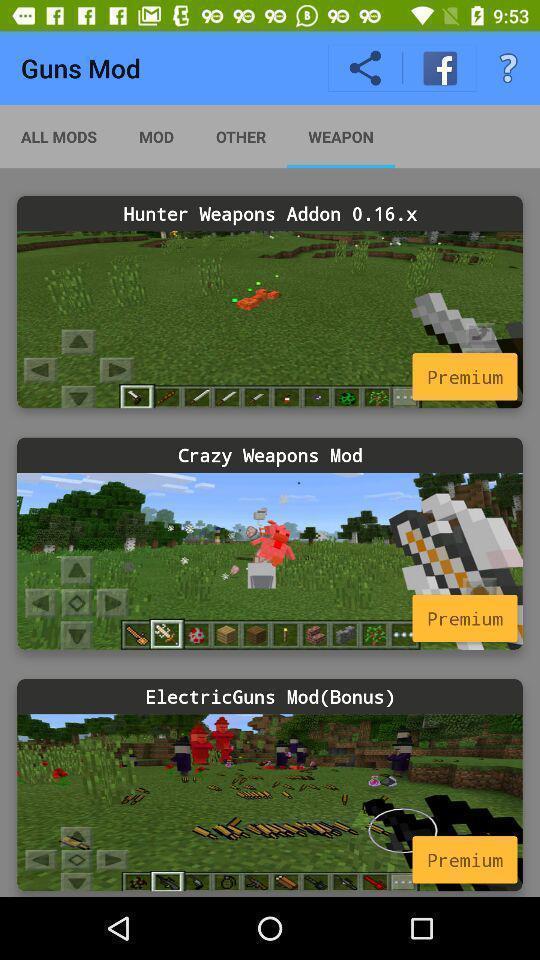Summarize the information in this screenshot. Page showing different game levels in the game app. 